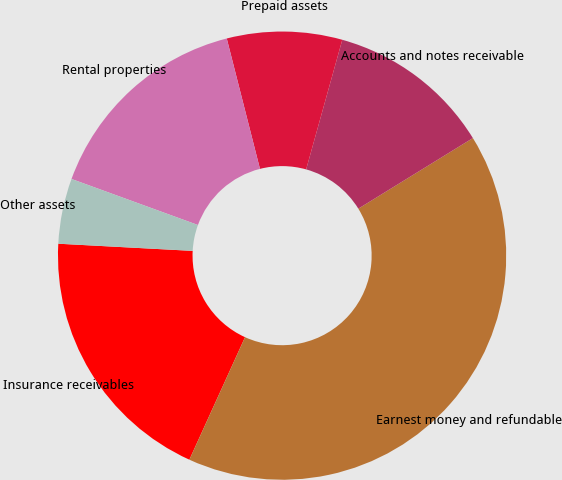<chart> <loc_0><loc_0><loc_500><loc_500><pie_chart><fcel>Insurance receivables<fcel>Earnest money and refundable<fcel>Accounts and notes receivable<fcel>Prepaid assets<fcel>Rental properties<fcel>Other assets<nl><fcel>19.06%<fcel>40.58%<fcel>11.88%<fcel>8.3%<fcel>15.47%<fcel>4.71%<nl></chart> 